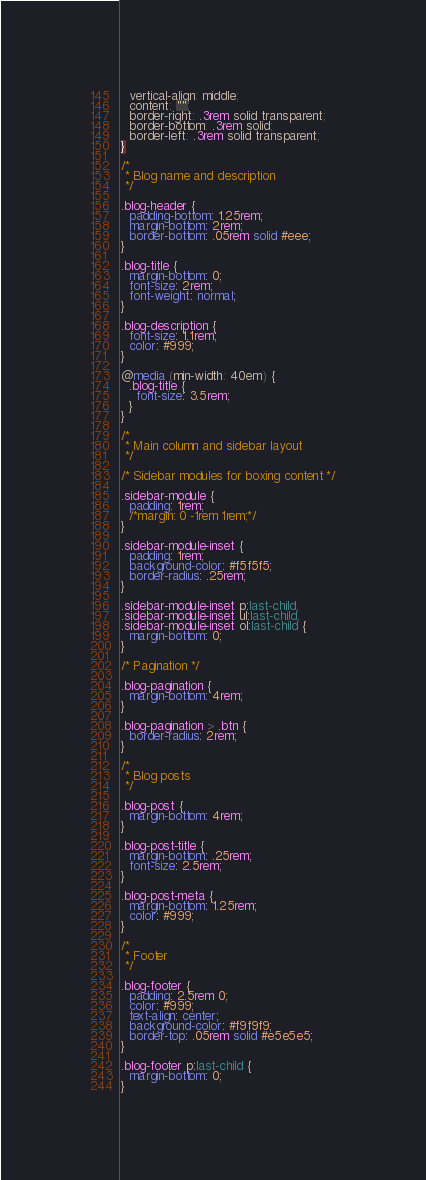Convert code to text. <code><loc_0><loc_0><loc_500><loc_500><_CSS_>  vertical-align: middle;
  content: "";
  border-right: .3rem solid transparent;
  border-bottom: .3rem solid;
  border-left: .3rem solid transparent;
}

/*
 * Blog name and description
 */

.blog-header {
  padding-bottom: 1.25rem;
  margin-bottom: 2rem;
  border-bottom: .05rem solid #eee;
}

.blog-title {
  margin-bottom: 0;
  font-size: 2rem;
  font-weight: normal;
}

.blog-description {
  font-size: 1.1rem;
  color: #999;
}

@media (min-width: 40em) {
  .blog-title {
    font-size: 3.5rem;
  }
}

/*
 * Main column and sidebar layout
 */

/* Sidebar modules for boxing content */

.sidebar-module {
  padding: 1rem;
  /*margin: 0 -1rem 1rem;*/
}

.sidebar-module-inset {
  padding: 1rem;
  background-color: #f5f5f5;
  border-radius: .25rem;
}

.sidebar-module-inset p:last-child,
.sidebar-module-inset ul:last-child,
.sidebar-module-inset ol:last-child {
  margin-bottom: 0;
}

/* Pagination */

.blog-pagination {
  margin-bottom: 4rem;
}

.blog-pagination > .btn {
  border-radius: 2rem;
}

/*
 * Blog posts
 */

.blog-post {
  margin-bottom: 4rem;
}

.blog-post-title {
  margin-bottom: .25rem;
  font-size: 2.5rem;
}

.blog-post-meta {
  margin-bottom: 1.25rem;
  color: #999;
}

/*
 * Footer
 */

.blog-footer {
  padding: 2.5rem 0;
  color: #999;
  text-align: center;
  background-color: #f9f9f9;
  border-top: .05rem solid #e5e5e5;
}

.blog-footer p:last-child {
  margin-bottom: 0;
}
</code> 